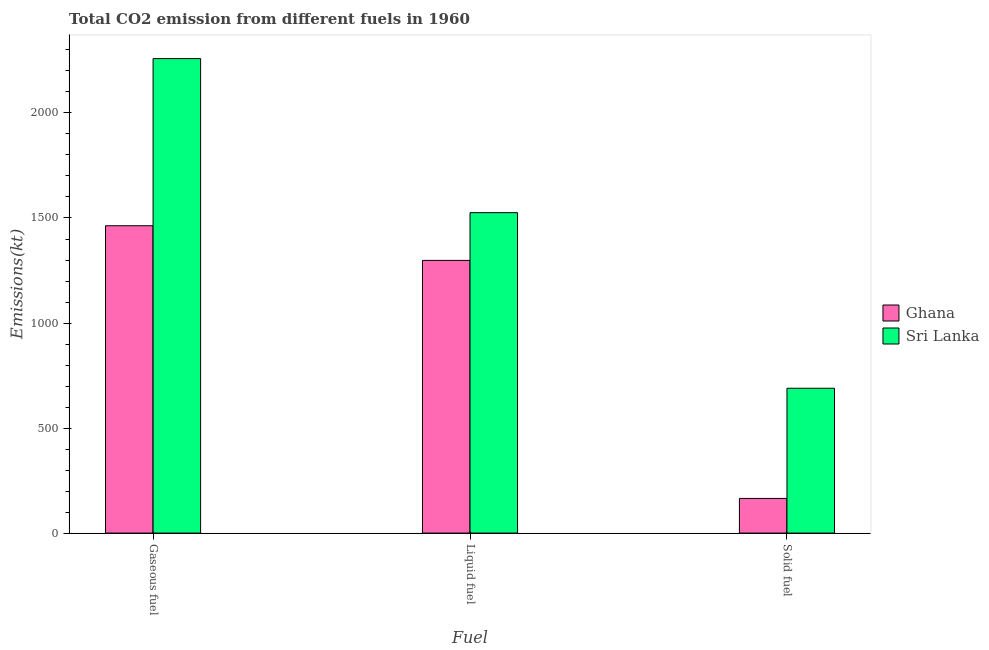Are the number of bars on each tick of the X-axis equal?
Ensure brevity in your answer.  Yes. How many bars are there on the 3rd tick from the right?
Provide a succinct answer. 2. What is the label of the 2nd group of bars from the left?
Offer a terse response. Liquid fuel. What is the amount of co2 emissions from liquid fuel in Ghana?
Your answer should be compact. 1298.12. Across all countries, what is the maximum amount of co2 emissions from gaseous fuel?
Give a very brief answer. 2258.87. Across all countries, what is the minimum amount of co2 emissions from gaseous fuel?
Your answer should be compact. 1463.13. In which country was the amount of co2 emissions from solid fuel maximum?
Offer a very short reply. Sri Lanka. In which country was the amount of co2 emissions from solid fuel minimum?
Provide a short and direct response. Ghana. What is the total amount of co2 emissions from solid fuel in the graph?
Offer a terse response. 854.41. What is the difference between the amount of co2 emissions from solid fuel in Sri Lanka and that in Ghana?
Make the answer very short. 524.38. What is the difference between the amount of co2 emissions from gaseous fuel in Ghana and the amount of co2 emissions from liquid fuel in Sri Lanka?
Ensure brevity in your answer.  -62.34. What is the average amount of co2 emissions from solid fuel per country?
Offer a terse response. 427.21. What is the difference between the amount of co2 emissions from gaseous fuel and amount of co2 emissions from solid fuel in Ghana?
Make the answer very short. 1298.12. In how many countries, is the amount of co2 emissions from gaseous fuel greater than 1600 kt?
Your response must be concise. 1. What is the ratio of the amount of co2 emissions from liquid fuel in Sri Lanka to that in Ghana?
Your response must be concise. 1.18. What is the difference between the highest and the second highest amount of co2 emissions from liquid fuel?
Provide a short and direct response. 227.35. What is the difference between the highest and the lowest amount of co2 emissions from liquid fuel?
Offer a terse response. 227.35. In how many countries, is the amount of co2 emissions from gaseous fuel greater than the average amount of co2 emissions from gaseous fuel taken over all countries?
Keep it short and to the point. 1. What does the 2nd bar from the right in Solid fuel represents?
Your response must be concise. Ghana. How many countries are there in the graph?
Your answer should be compact. 2. Where does the legend appear in the graph?
Your answer should be very brief. Center right. How are the legend labels stacked?
Your answer should be very brief. Vertical. What is the title of the graph?
Keep it short and to the point. Total CO2 emission from different fuels in 1960. What is the label or title of the X-axis?
Give a very brief answer. Fuel. What is the label or title of the Y-axis?
Provide a succinct answer. Emissions(kt). What is the Emissions(kt) in Ghana in Gaseous fuel?
Provide a succinct answer. 1463.13. What is the Emissions(kt) in Sri Lanka in Gaseous fuel?
Give a very brief answer. 2258.87. What is the Emissions(kt) in Ghana in Liquid fuel?
Offer a very short reply. 1298.12. What is the Emissions(kt) in Sri Lanka in Liquid fuel?
Ensure brevity in your answer.  1525.47. What is the Emissions(kt) of Ghana in Solid fuel?
Offer a terse response. 165.01. What is the Emissions(kt) in Sri Lanka in Solid fuel?
Keep it short and to the point. 689.4. Across all Fuel, what is the maximum Emissions(kt) of Ghana?
Your answer should be very brief. 1463.13. Across all Fuel, what is the maximum Emissions(kt) in Sri Lanka?
Your answer should be compact. 2258.87. Across all Fuel, what is the minimum Emissions(kt) of Ghana?
Your answer should be compact. 165.01. Across all Fuel, what is the minimum Emissions(kt) of Sri Lanka?
Your response must be concise. 689.4. What is the total Emissions(kt) of Ghana in the graph?
Ensure brevity in your answer.  2926.27. What is the total Emissions(kt) of Sri Lanka in the graph?
Provide a short and direct response. 4473.74. What is the difference between the Emissions(kt) in Ghana in Gaseous fuel and that in Liquid fuel?
Your answer should be compact. 165.01. What is the difference between the Emissions(kt) in Sri Lanka in Gaseous fuel and that in Liquid fuel?
Keep it short and to the point. 733.4. What is the difference between the Emissions(kt) in Ghana in Gaseous fuel and that in Solid fuel?
Offer a very short reply. 1298.12. What is the difference between the Emissions(kt) of Sri Lanka in Gaseous fuel and that in Solid fuel?
Offer a terse response. 1569.48. What is the difference between the Emissions(kt) of Ghana in Liquid fuel and that in Solid fuel?
Provide a short and direct response. 1133.1. What is the difference between the Emissions(kt) of Sri Lanka in Liquid fuel and that in Solid fuel?
Offer a terse response. 836.08. What is the difference between the Emissions(kt) of Ghana in Gaseous fuel and the Emissions(kt) of Sri Lanka in Liquid fuel?
Offer a very short reply. -62.34. What is the difference between the Emissions(kt) of Ghana in Gaseous fuel and the Emissions(kt) of Sri Lanka in Solid fuel?
Your answer should be very brief. 773.74. What is the difference between the Emissions(kt) of Ghana in Liquid fuel and the Emissions(kt) of Sri Lanka in Solid fuel?
Give a very brief answer. 608.72. What is the average Emissions(kt) in Ghana per Fuel?
Give a very brief answer. 975.42. What is the average Emissions(kt) of Sri Lanka per Fuel?
Give a very brief answer. 1491.25. What is the difference between the Emissions(kt) of Ghana and Emissions(kt) of Sri Lanka in Gaseous fuel?
Give a very brief answer. -795.74. What is the difference between the Emissions(kt) of Ghana and Emissions(kt) of Sri Lanka in Liquid fuel?
Your response must be concise. -227.35. What is the difference between the Emissions(kt) in Ghana and Emissions(kt) in Sri Lanka in Solid fuel?
Your response must be concise. -524.38. What is the ratio of the Emissions(kt) of Ghana in Gaseous fuel to that in Liquid fuel?
Offer a very short reply. 1.13. What is the ratio of the Emissions(kt) of Sri Lanka in Gaseous fuel to that in Liquid fuel?
Your answer should be very brief. 1.48. What is the ratio of the Emissions(kt) of Ghana in Gaseous fuel to that in Solid fuel?
Give a very brief answer. 8.87. What is the ratio of the Emissions(kt) in Sri Lanka in Gaseous fuel to that in Solid fuel?
Your answer should be very brief. 3.28. What is the ratio of the Emissions(kt) of Ghana in Liquid fuel to that in Solid fuel?
Offer a terse response. 7.87. What is the ratio of the Emissions(kt) in Sri Lanka in Liquid fuel to that in Solid fuel?
Give a very brief answer. 2.21. What is the difference between the highest and the second highest Emissions(kt) of Ghana?
Offer a very short reply. 165.01. What is the difference between the highest and the second highest Emissions(kt) in Sri Lanka?
Ensure brevity in your answer.  733.4. What is the difference between the highest and the lowest Emissions(kt) in Ghana?
Your answer should be compact. 1298.12. What is the difference between the highest and the lowest Emissions(kt) in Sri Lanka?
Your response must be concise. 1569.48. 